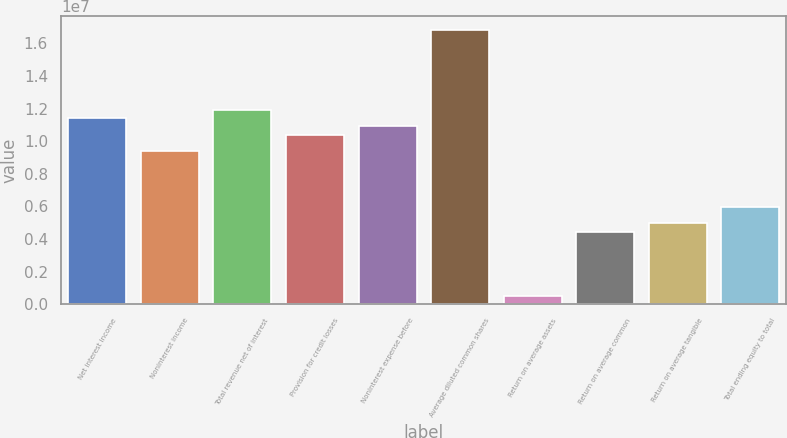<chart> <loc_0><loc_0><loc_500><loc_500><bar_chart><fcel>Net interest income<fcel>Noninterest income<fcel>Total revenue net of interest<fcel>Provision for credit losses<fcel>Noninterest expense before<fcel>Average diluted common shares<fcel>Return on average assets<fcel>Return on average common<fcel>Return on average tangible<fcel>Total ending equity to total<nl><fcel>1.14012e+07<fcel>9.41839e+06<fcel>1.18969e+07<fcel>1.04098e+07<fcel>1.09055e+07<fcel>1.6854e+07<fcel>495705<fcel>4.46134e+06<fcel>4.95705e+06<fcel>5.94846e+06<nl></chart> 